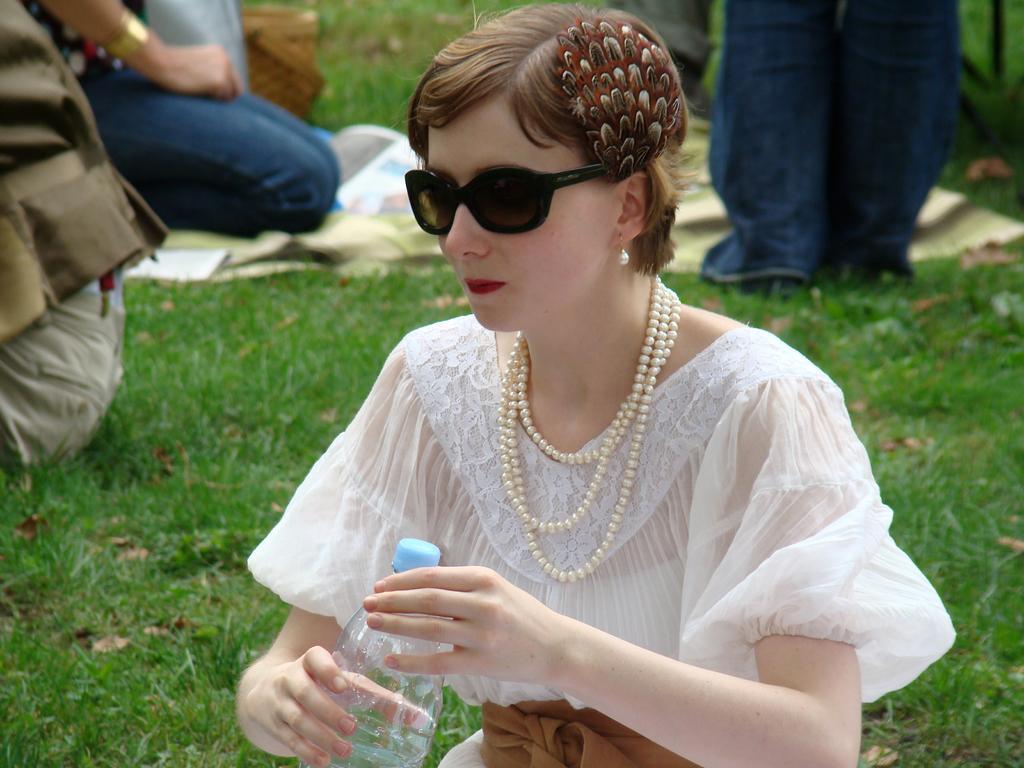Describe this image in one or two sentences. Here is the woman sitting. She wore white dress,goggles,earrings and pearl necklace. She holding holding a water bottle in her hand. Background I can see few people sitting and standing. This is the grass. 